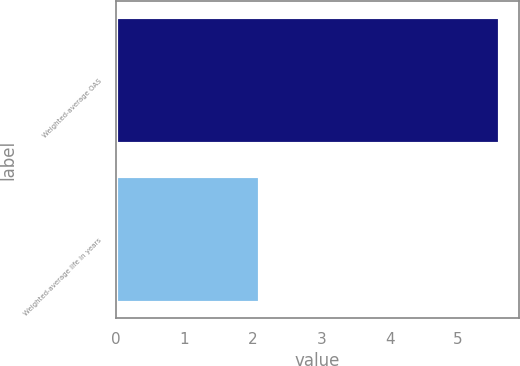Convert chart. <chart><loc_0><loc_0><loc_500><loc_500><bar_chart><fcel>Weighted-average OAS<fcel>Weighted-average life in years<nl><fcel>5.61<fcel>2.1<nl></chart> 